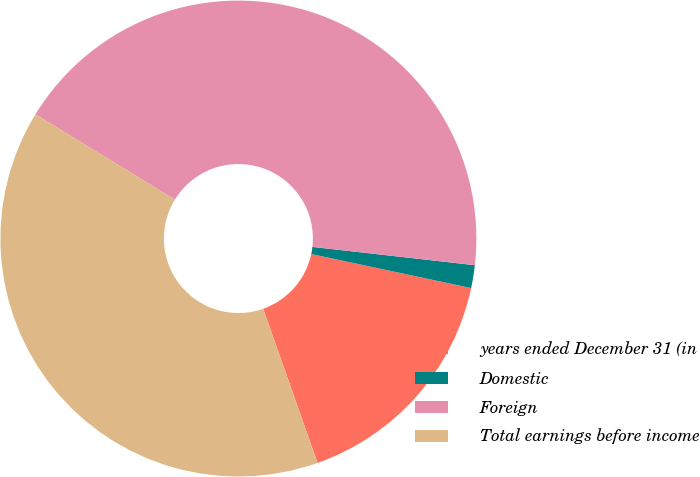Convert chart to OTSL. <chart><loc_0><loc_0><loc_500><loc_500><pie_chart><fcel>years ended December 31 (in<fcel>Domestic<fcel>Foreign<fcel>Total earnings before income<nl><fcel>16.27%<fcel>1.55%<fcel>43.05%<fcel>39.14%<nl></chart> 